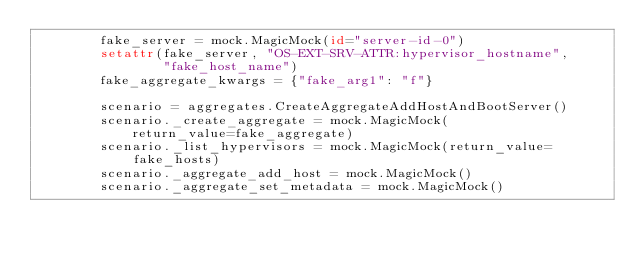Convert code to text. <code><loc_0><loc_0><loc_500><loc_500><_Python_>        fake_server = mock.MagicMock(id="server-id-0")
        setattr(fake_server, "OS-EXT-SRV-ATTR:hypervisor_hostname",
                "fake_host_name")
        fake_aggregate_kwargs = {"fake_arg1": "f"}

        scenario = aggregates.CreateAggregateAddHostAndBootServer()
        scenario._create_aggregate = mock.MagicMock(
            return_value=fake_aggregate)
        scenario._list_hypervisors = mock.MagicMock(return_value=fake_hosts)
        scenario._aggregate_add_host = mock.MagicMock()
        scenario._aggregate_set_metadata = mock.MagicMock()</code> 